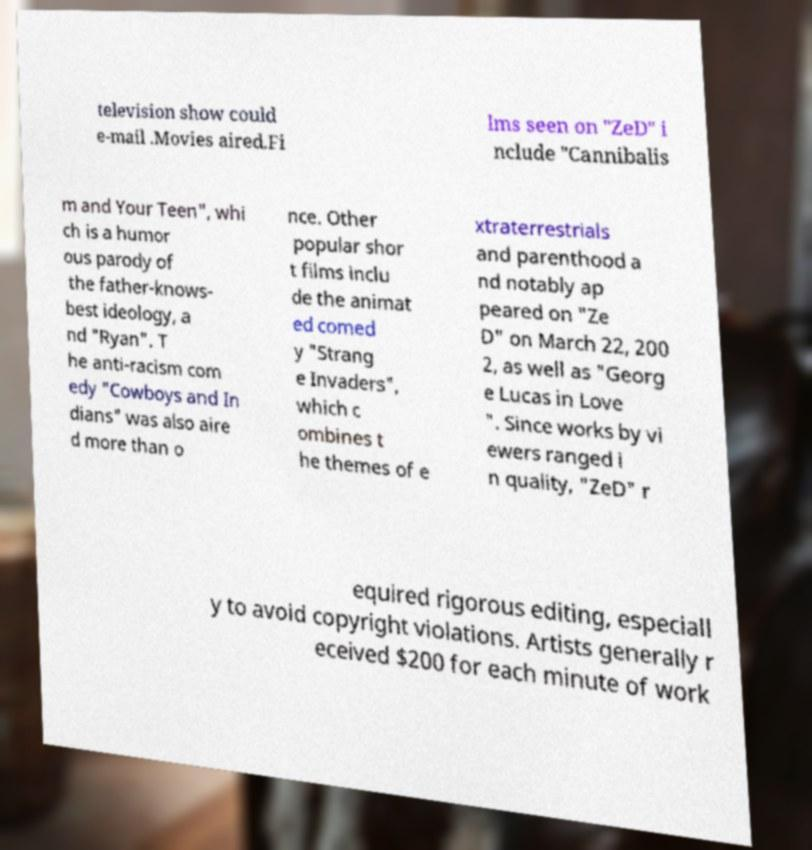Please read and relay the text visible in this image. What does it say? television show could e-mail .Movies aired.Fi lms seen on "ZeD" i nclude "Cannibalis m and Your Teen", whi ch is a humor ous parody of the father-knows- best ideology, a nd "Ryan". T he anti-racism com edy "Cowboys and In dians" was also aire d more than o nce. Other popular shor t films inclu de the animat ed comed y "Strang e Invaders", which c ombines t he themes of e xtraterrestrials and parenthood a nd notably ap peared on "Ze D" on March 22, 200 2, as well as "Georg e Lucas in Love ". Since works by vi ewers ranged i n quality, "ZeD" r equired rigorous editing, especiall y to avoid copyright violations. Artists generally r eceived $200 for each minute of work 